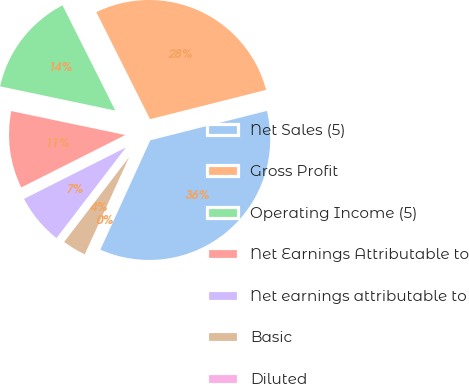<chart> <loc_0><loc_0><loc_500><loc_500><pie_chart><fcel>Net Sales (5)<fcel>Gross Profit<fcel>Operating Income (5)<fcel>Net Earnings Attributable to<fcel>Net earnings attributable to<fcel>Basic<fcel>Diluted<nl><fcel>35.74%<fcel>28.47%<fcel>14.3%<fcel>10.73%<fcel>7.16%<fcel>3.58%<fcel>0.01%<nl></chart> 